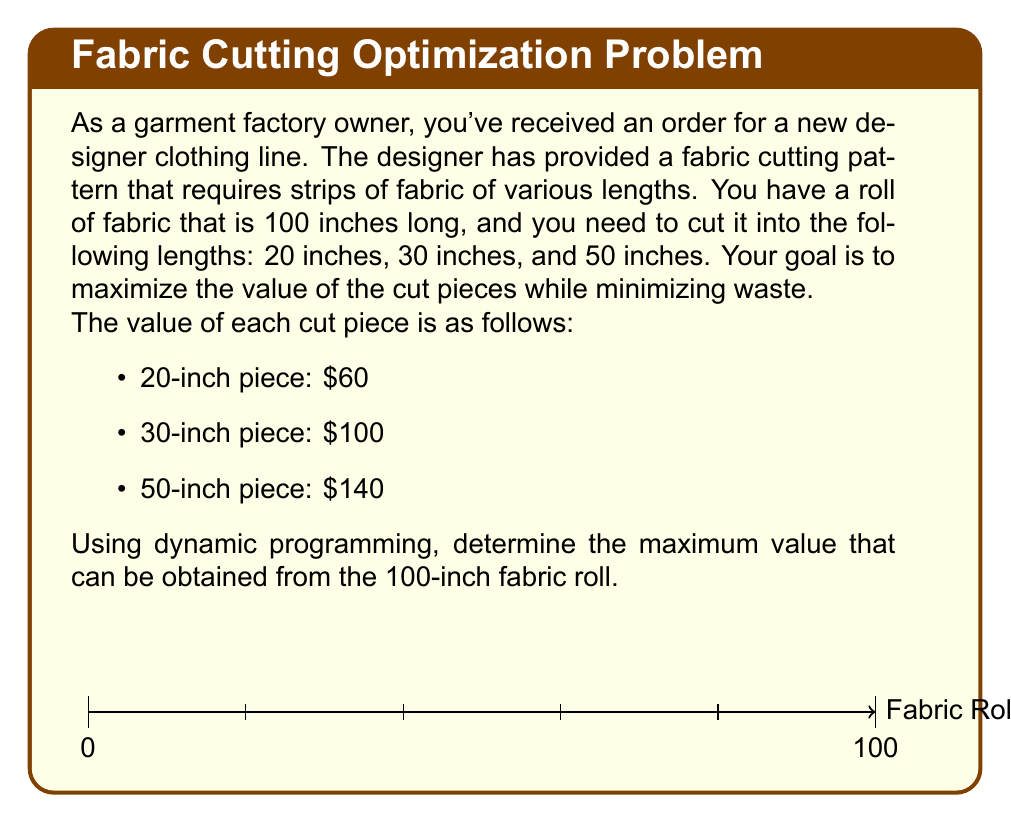Teach me how to tackle this problem. Let's solve this problem using dynamic programming:

1) Define the subproblem:
   Let $V(n)$ be the maximum value that can be obtained from a fabric of length $n$ inches.

2) Establish the recurrence relation:
   $$V(n) = \max \begin{cases}
   60 + V(n-20) & \text{if } n \geq 20 \\
   100 + V(n-30) & \text{if } n \geq 30 \\
   140 + V(n-50) & \text{if } n \geq 50 \\
   0 & \text{otherwise}
   \end{cases}$$

3) Initialize the base cases:
   $V(0) = 0$
   $V(n) = 0$ for $n < 20$

4) Compute the values bottom-up:

   $V(20) = 60$
   $V(30) = 100$
   $V(40) = 120$ (two 20-inch pieces)
   $V(50) = 140$
   $V(60) = 200$ (two 30-inch pieces)
   $V(70) = 220$ (one 50-inch piece + one 20-inch piece)
   $V(80) = 240$ (four 20-inch pieces)
   $V(90) = 300$ (three 30-inch pieces)
   $V(100) = 340$ (two 50-inch pieces)

5) The maximum value for the 100-inch fabric roll is $V(100) = 340$.

This can be achieved by cutting the fabric into two 50-inch pieces.
Answer: $340 